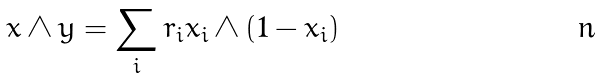Convert formula to latex. <formula><loc_0><loc_0><loc_500><loc_500>x \wedge y = \sum _ { i } r _ { i } x _ { i } \wedge ( 1 - x _ { i } )</formula> 